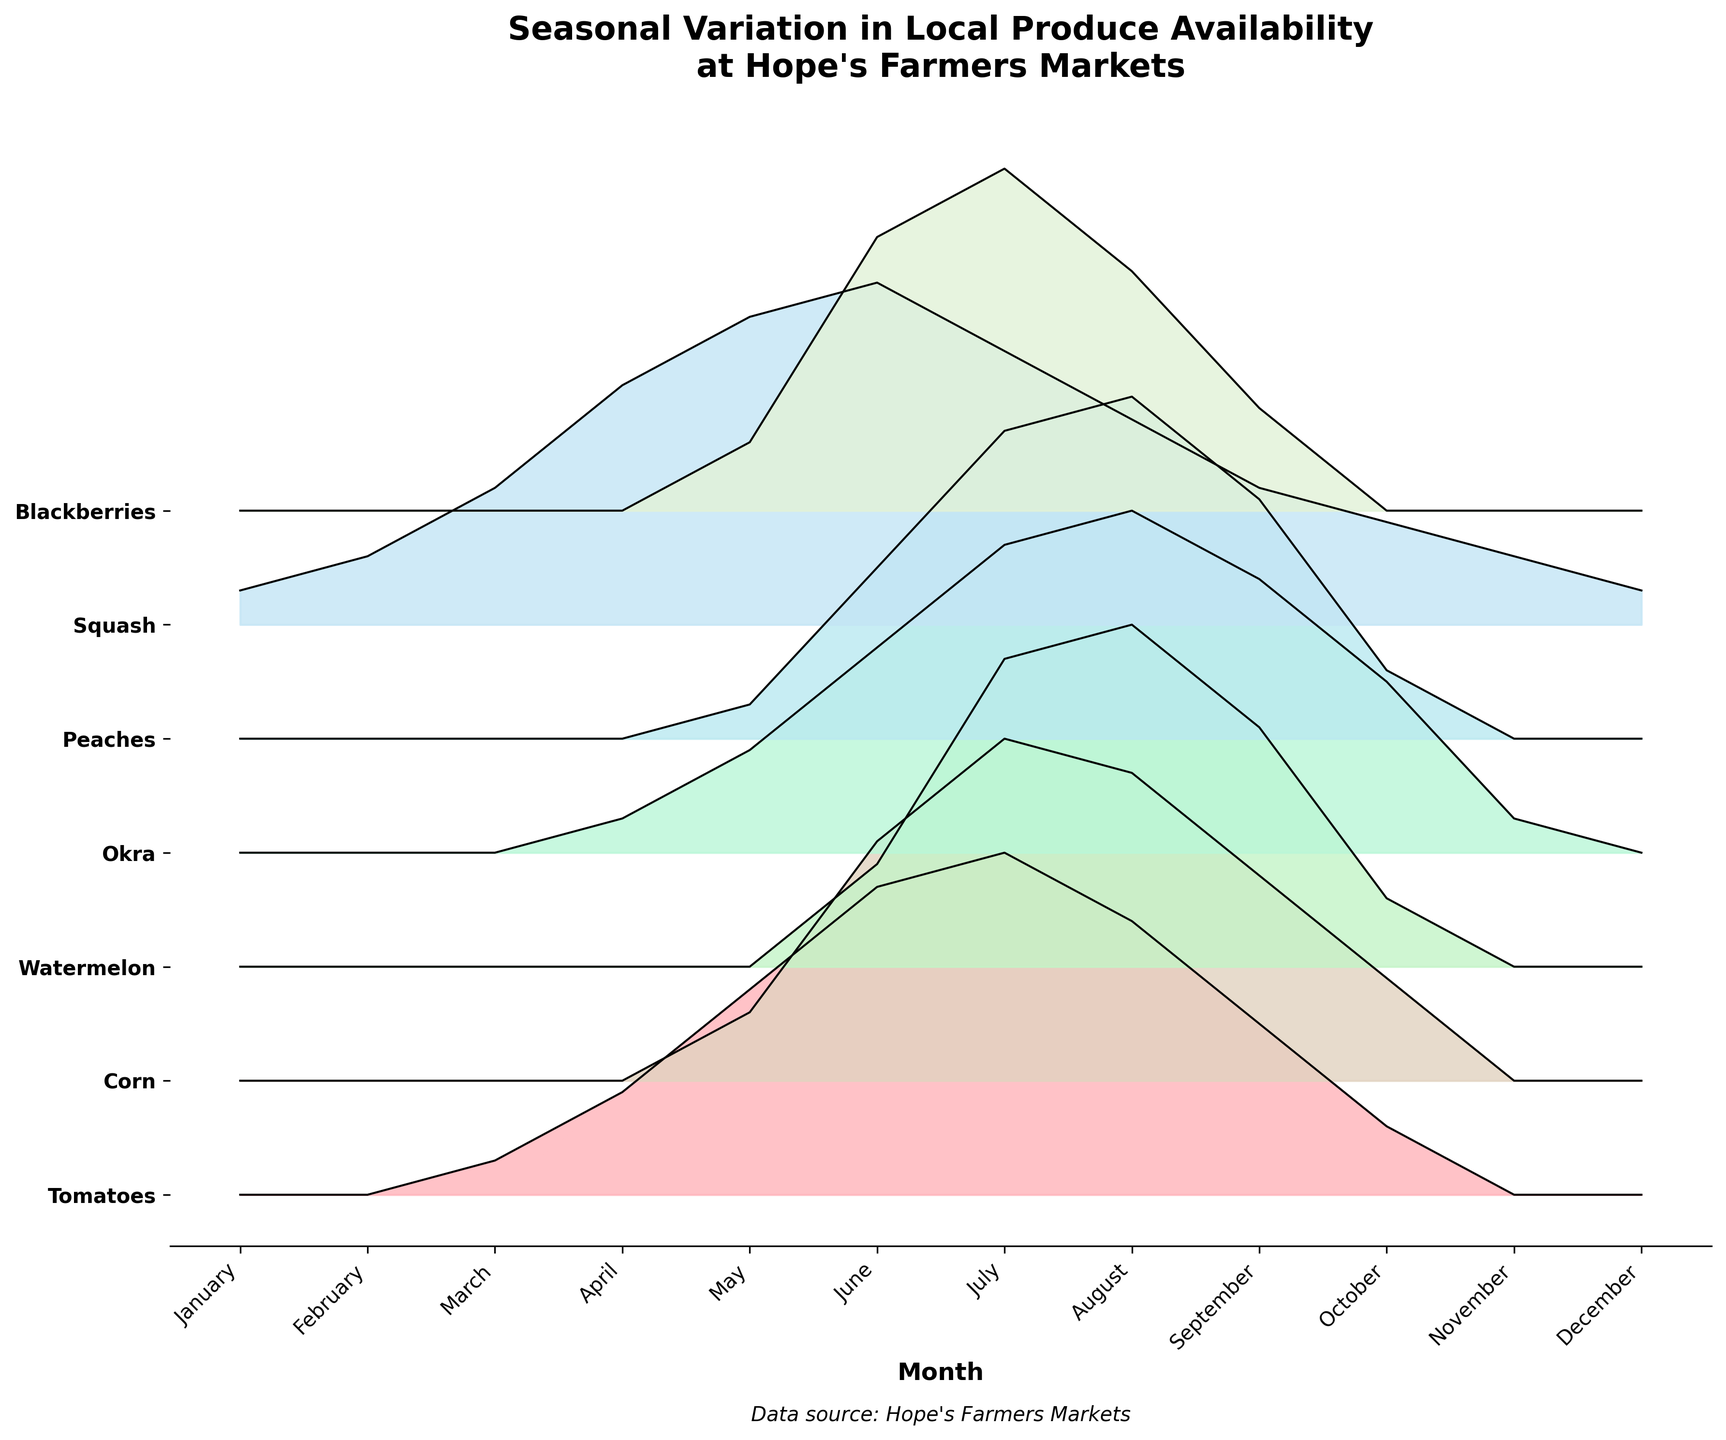What is the title of the plot? The title is often displayed at the top of a plot and summarizes the main information being visually presented. In this case, it is directly stated above the chart.
Answer: Seasonal Variation in Local Produce Availability at Hope's Farmers Markets Which produce item has the highest value in July? To find the highest value in July, locate July along the x-axis and then find the peak within the bands representing each produce item.
Answer: Tomatoes What are the colors used in the plot? The colors in the plot are used to differentiate the produce items. These colors can be found by looking at the filled areas under the curves for each item.
Answer: Pink, Green, Blue, Yellow Which months have no Tomatoes available? By scanning the plot along the x-axis for each month, check where the band for Tomatoes has zero height.
Answer: January, February, November, December What produce items are available all year round? Items that have non-zero values at all months are represented with a continuous band throughout the year.
Answer: Squash In which month is the availability of Peaches the highest? Check the peaks of the band corresponding to Peaches and identify the month along the x-axis where this peak occurs.
Answer: August Which two produce items have the closest availability in August? Look at the height of the bands for each produce item in August and compare their values to find the closest ones.
Answer: Corn and Watermelon How many produce items have increased availability from January to July? Compare the heights of the bands from January to July for each produce item and count those that show an increase.
Answer: Six What is the general trend for Blackberries from July to October? Observing the band for Blackberries from July to October, note whether the height is increasing, decreasing, or remaining stable across these months.
Answer: Decreasing How does the availability of Okra compare between May and September? Compare the heights of the Okra band above May and September to determine which month has more availability.
Answer: September is higher than May 